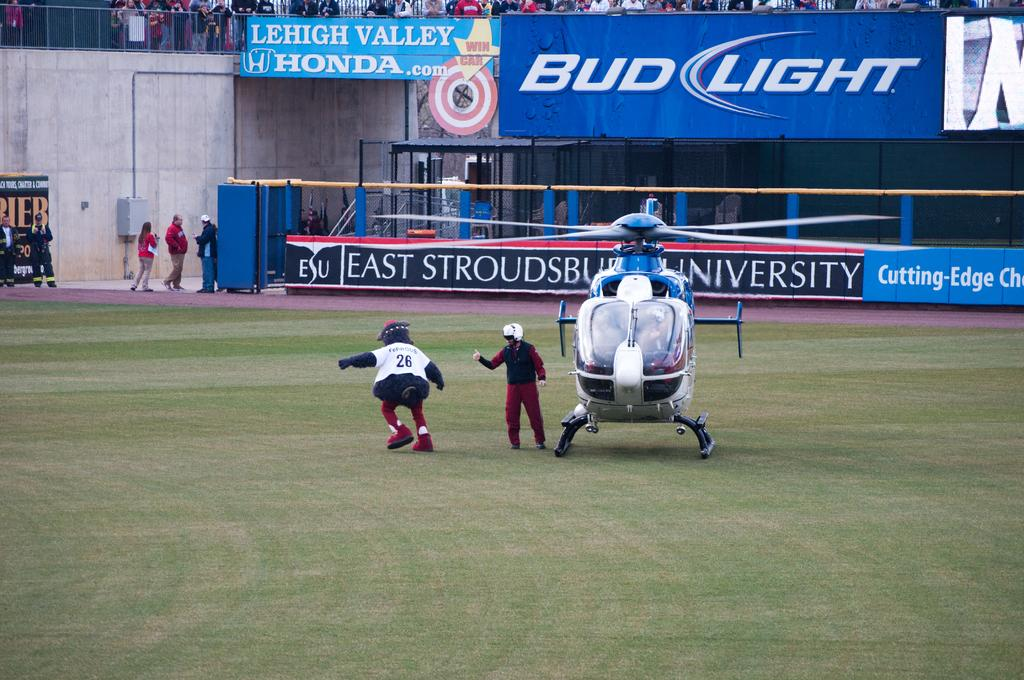<image>
Present a compact description of the photo's key features. number 28 on a baseball field where there are signs that say bud light on the sidelines 